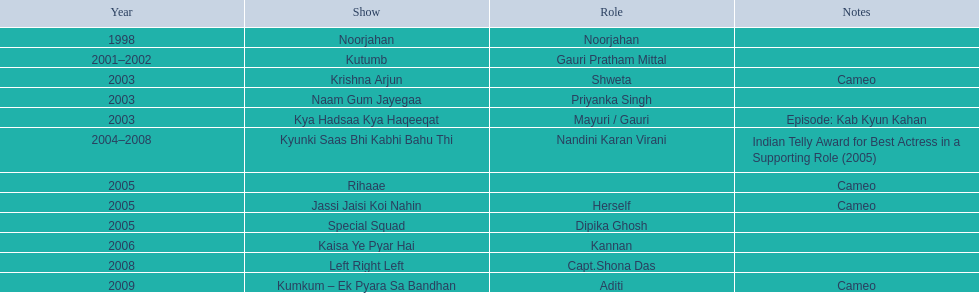Which television productions starred gauri pradhan tejwani? Noorjahan, Kutumb, Krishna Arjun, Naam Gum Jayegaa, Kya Hadsaa Kya Haqeeqat, Kyunki Saas Bhi Kabhi Bahu Thi, Rihaae, Jassi Jaisi Koi Nahin, Special Squad, Kaisa Ye Pyar Hai, Left Right Left, Kumkum – Ek Pyara Sa Bandhan. Of these, which were minor appearances? Krishna Arjun, Rihaae, Jassi Jaisi Koi Nahin, Kumkum – Ek Pyara Sa Bandhan. Of these, in which did she represent herself? Jassi Jaisi Koi Nahin. 